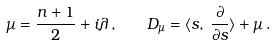<formula> <loc_0><loc_0><loc_500><loc_500>\mu = \frac { n + 1 } 2 + i \lambda \, , \quad D _ { \mu } = \langle s , \, \frac { \partial } { \partial s } \rangle + \mu \, .</formula> 